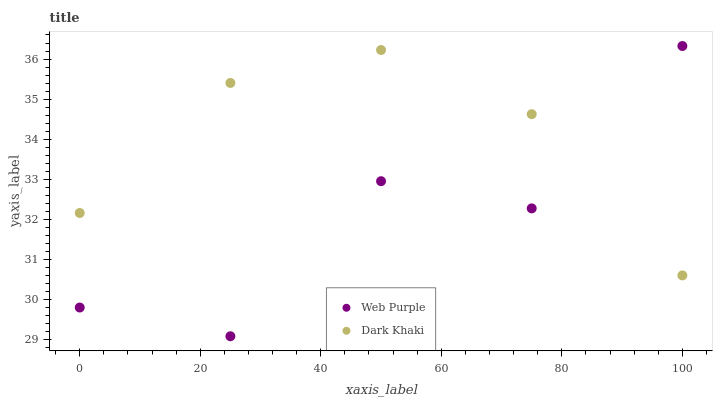Does Web Purple have the minimum area under the curve?
Answer yes or no. Yes. Does Dark Khaki have the maximum area under the curve?
Answer yes or no. Yes. Does Web Purple have the maximum area under the curve?
Answer yes or no. No. Is Dark Khaki the smoothest?
Answer yes or no. Yes. Is Web Purple the roughest?
Answer yes or no. Yes. Is Web Purple the smoothest?
Answer yes or no. No. Does Web Purple have the lowest value?
Answer yes or no. Yes. Does Web Purple have the highest value?
Answer yes or no. Yes. Does Dark Khaki intersect Web Purple?
Answer yes or no. Yes. Is Dark Khaki less than Web Purple?
Answer yes or no. No. Is Dark Khaki greater than Web Purple?
Answer yes or no. No. 